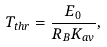Convert formula to latex. <formula><loc_0><loc_0><loc_500><loc_500>T _ { t h r } = \frac { E _ { 0 } } { R _ { B } K _ { a v } } ,</formula> 